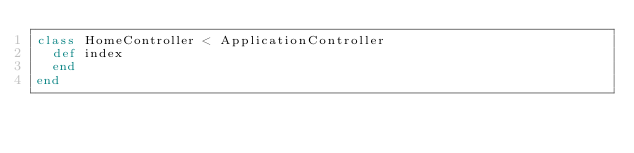Convert code to text. <code><loc_0><loc_0><loc_500><loc_500><_Ruby_>class HomeController < ApplicationController
  def index
  end
end

</code> 